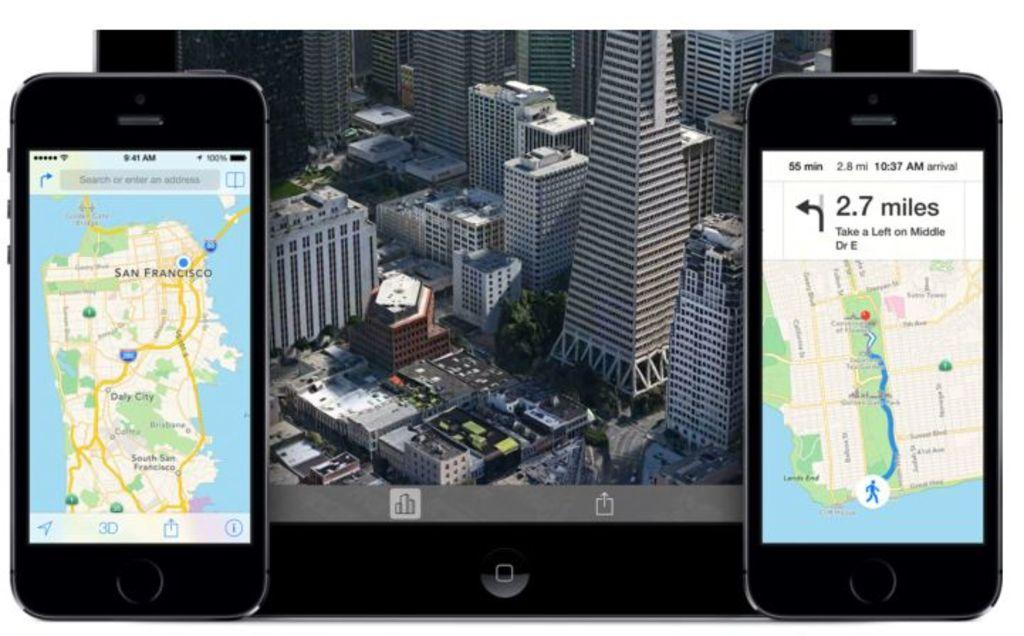Provide a one-sentence caption for the provided image. Screen of a phone showing directions to an area which takes 2.7 miles. 